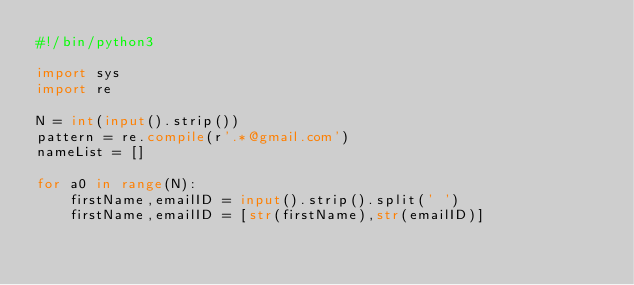<code> <loc_0><loc_0><loc_500><loc_500><_Python_>#!/bin/python3

import sys
import re

N = int(input().strip())
pattern = re.compile(r'.*@gmail.com')
nameList = []

for a0 in range(N):
    firstName,emailID = input().strip().split(' ')
    firstName,emailID = [str(firstName),str(emailID)]</code> 